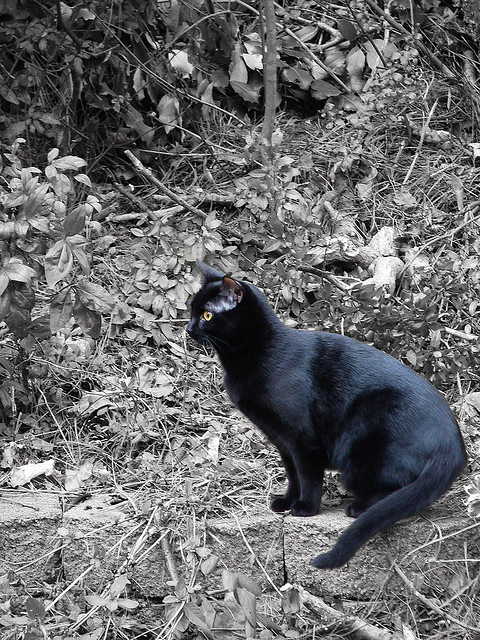Describe the objects in this image and their specific colors. I can see a cat in black, gray, and blue tones in this image. 